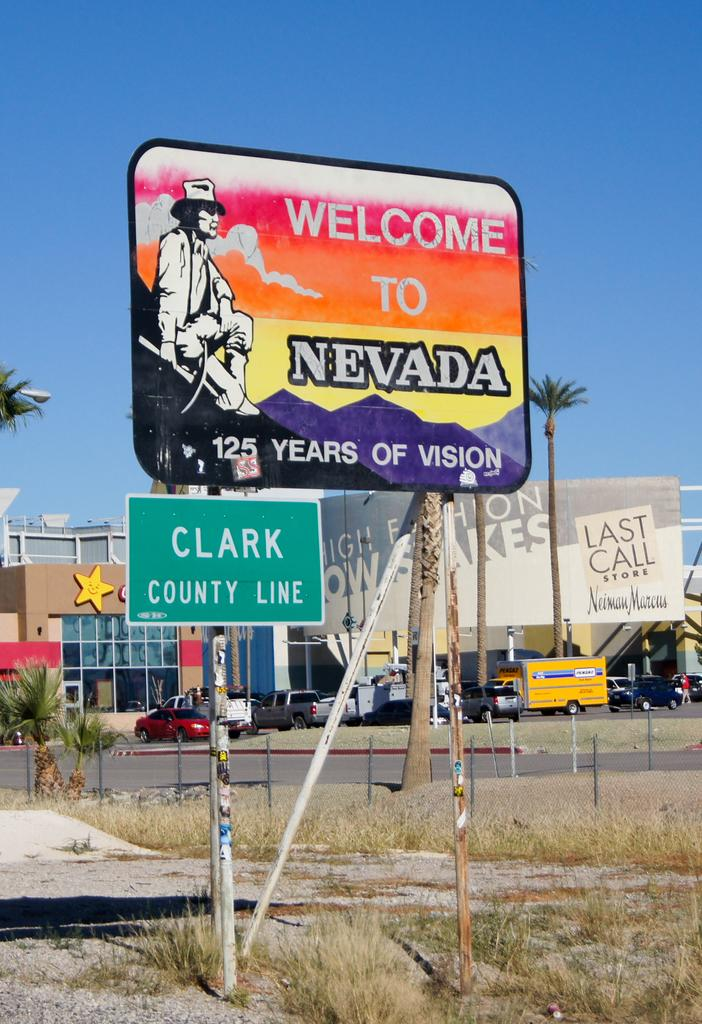<image>
Present a compact description of the photo's key features. The county that is pictured is Clark County Nevada 